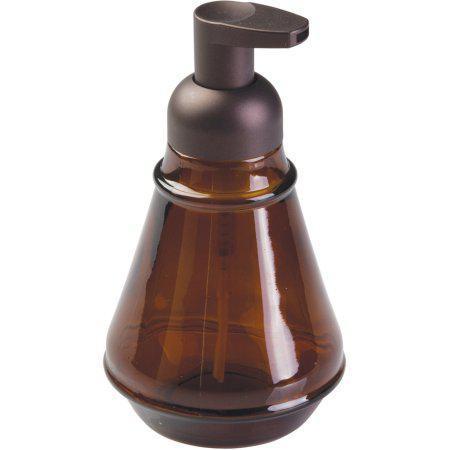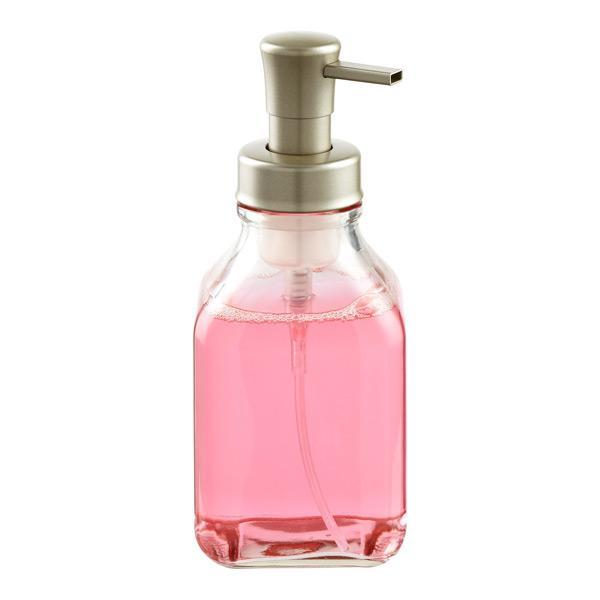The first image is the image on the left, the second image is the image on the right. Given the left and right images, does the statement "The soap dispenser in the left image contains blue soap." hold true? Answer yes or no. No. 